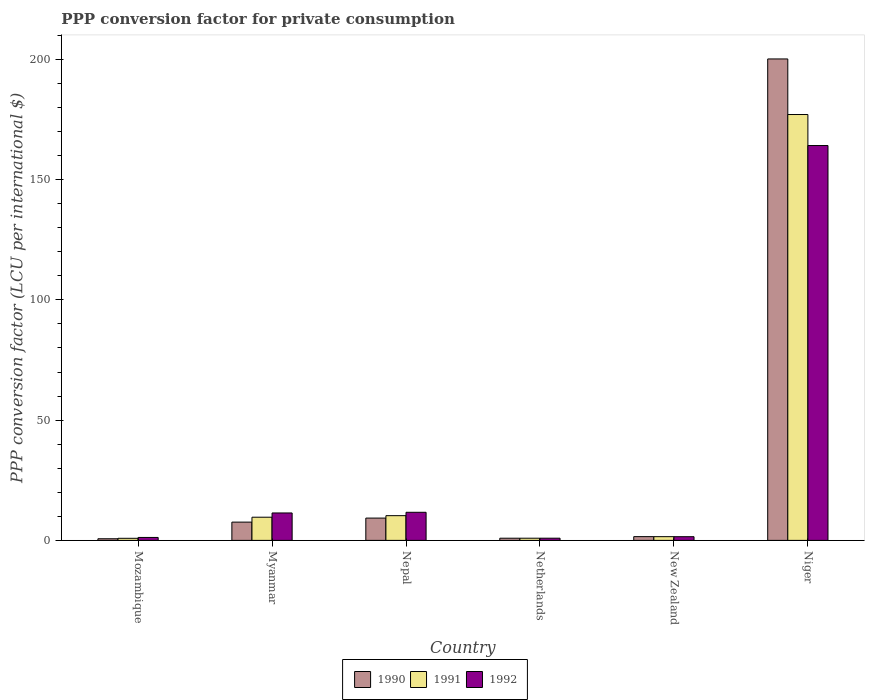Are the number of bars on each tick of the X-axis equal?
Ensure brevity in your answer.  Yes. What is the label of the 5th group of bars from the left?
Your answer should be compact. New Zealand. What is the PPP conversion factor for private consumption in 1991 in Myanmar?
Keep it short and to the point. 9.64. Across all countries, what is the maximum PPP conversion factor for private consumption in 1991?
Give a very brief answer. 177.06. Across all countries, what is the minimum PPP conversion factor for private consumption in 1991?
Provide a succinct answer. 0.87. In which country was the PPP conversion factor for private consumption in 1991 maximum?
Ensure brevity in your answer.  Niger. In which country was the PPP conversion factor for private consumption in 1990 minimum?
Ensure brevity in your answer.  Mozambique. What is the total PPP conversion factor for private consumption in 1990 in the graph?
Offer a very short reply. 220.18. What is the difference between the PPP conversion factor for private consumption in 1992 in Mozambique and that in Myanmar?
Give a very brief answer. -10.18. What is the difference between the PPP conversion factor for private consumption in 1991 in Myanmar and the PPP conversion factor for private consumption in 1990 in Mozambique?
Make the answer very short. 8.96. What is the average PPP conversion factor for private consumption in 1992 per country?
Keep it short and to the point. 31.82. What is the difference between the PPP conversion factor for private consumption of/in 1990 and PPP conversion factor for private consumption of/in 1991 in Niger?
Your answer should be compact. 23.1. In how many countries, is the PPP conversion factor for private consumption in 1992 greater than 80 LCU?
Provide a short and direct response. 1. What is the ratio of the PPP conversion factor for private consumption in 1992 in Myanmar to that in Netherlands?
Your answer should be compact. 12.49. Is the difference between the PPP conversion factor for private consumption in 1990 in Mozambique and Nepal greater than the difference between the PPP conversion factor for private consumption in 1991 in Mozambique and Nepal?
Give a very brief answer. Yes. What is the difference between the highest and the second highest PPP conversion factor for private consumption in 1990?
Ensure brevity in your answer.  190.89. What is the difference between the highest and the lowest PPP conversion factor for private consumption in 1992?
Your response must be concise. 163.25. In how many countries, is the PPP conversion factor for private consumption in 1992 greater than the average PPP conversion factor for private consumption in 1992 taken over all countries?
Your answer should be compact. 1. What does the 1st bar from the right in Myanmar represents?
Your answer should be very brief. 1992. Is it the case that in every country, the sum of the PPP conversion factor for private consumption in 1992 and PPP conversion factor for private consumption in 1990 is greater than the PPP conversion factor for private consumption in 1991?
Offer a terse response. Yes. How many bars are there?
Keep it short and to the point. 18. How many countries are there in the graph?
Your answer should be compact. 6. Are the values on the major ticks of Y-axis written in scientific E-notation?
Offer a terse response. No. Does the graph contain any zero values?
Provide a short and direct response. No. How many legend labels are there?
Keep it short and to the point. 3. How are the legend labels stacked?
Offer a terse response. Horizontal. What is the title of the graph?
Your answer should be compact. PPP conversion factor for private consumption. Does "1961" appear as one of the legend labels in the graph?
Provide a succinct answer. No. What is the label or title of the X-axis?
Ensure brevity in your answer.  Country. What is the label or title of the Y-axis?
Your response must be concise. PPP conversion factor (LCU per international $). What is the PPP conversion factor (LCU per international $) in 1990 in Mozambique?
Your response must be concise. 0.68. What is the PPP conversion factor (LCU per international $) in 1991 in Mozambique?
Give a very brief answer. 0.87. What is the PPP conversion factor (LCU per international $) in 1992 in Mozambique?
Offer a terse response. 1.22. What is the PPP conversion factor (LCU per international $) in 1990 in Myanmar?
Your answer should be very brief. 7.6. What is the PPP conversion factor (LCU per international $) in 1991 in Myanmar?
Provide a succinct answer. 9.64. What is the PPP conversion factor (LCU per international $) of 1992 in Myanmar?
Give a very brief answer. 11.41. What is the PPP conversion factor (LCU per international $) in 1990 in Nepal?
Ensure brevity in your answer.  9.27. What is the PPP conversion factor (LCU per international $) in 1991 in Nepal?
Provide a succinct answer. 10.28. What is the PPP conversion factor (LCU per international $) of 1992 in Nepal?
Ensure brevity in your answer.  11.69. What is the PPP conversion factor (LCU per international $) of 1990 in Netherlands?
Your answer should be compact. 0.91. What is the PPP conversion factor (LCU per international $) in 1991 in Netherlands?
Your answer should be very brief. 0.91. What is the PPP conversion factor (LCU per international $) in 1992 in Netherlands?
Offer a terse response. 0.91. What is the PPP conversion factor (LCU per international $) of 1990 in New Zealand?
Offer a very short reply. 1.56. What is the PPP conversion factor (LCU per international $) of 1991 in New Zealand?
Your response must be concise. 1.55. What is the PPP conversion factor (LCU per international $) of 1992 in New Zealand?
Keep it short and to the point. 1.53. What is the PPP conversion factor (LCU per international $) in 1990 in Niger?
Provide a succinct answer. 200.16. What is the PPP conversion factor (LCU per international $) in 1991 in Niger?
Provide a succinct answer. 177.06. What is the PPP conversion factor (LCU per international $) in 1992 in Niger?
Your response must be concise. 164.16. Across all countries, what is the maximum PPP conversion factor (LCU per international $) of 1990?
Your response must be concise. 200.16. Across all countries, what is the maximum PPP conversion factor (LCU per international $) of 1991?
Make the answer very short. 177.06. Across all countries, what is the maximum PPP conversion factor (LCU per international $) in 1992?
Make the answer very short. 164.16. Across all countries, what is the minimum PPP conversion factor (LCU per international $) in 1990?
Your response must be concise. 0.68. Across all countries, what is the minimum PPP conversion factor (LCU per international $) in 1991?
Provide a succinct answer. 0.87. Across all countries, what is the minimum PPP conversion factor (LCU per international $) of 1992?
Keep it short and to the point. 0.91. What is the total PPP conversion factor (LCU per international $) in 1990 in the graph?
Give a very brief answer. 220.18. What is the total PPP conversion factor (LCU per international $) of 1991 in the graph?
Your response must be concise. 200.3. What is the total PPP conversion factor (LCU per international $) in 1992 in the graph?
Keep it short and to the point. 190.92. What is the difference between the PPP conversion factor (LCU per international $) in 1990 in Mozambique and that in Myanmar?
Give a very brief answer. -6.92. What is the difference between the PPP conversion factor (LCU per international $) of 1991 in Mozambique and that in Myanmar?
Keep it short and to the point. -8.77. What is the difference between the PPP conversion factor (LCU per international $) of 1992 in Mozambique and that in Myanmar?
Provide a short and direct response. -10.18. What is the difference between the PPP conversion factor (LCU per international $) in 1990 in Mozambique and that in Nepal?
Provide a short and direct response. -8.59. What is the difference between the PPP conversion factor (LCU per international $) in 1991 in Mozambique and that in Nepal?
Make the answer very short. -9.41. What is the difference between the PPP conversion factor (LCU per international $) of 1992 in Mozambique and that in Nepal?
Ensure brevity in your answer.  -10.46. What is the difference between the PPP conversion factor (LCU per international $) in 1990 in Mozambique and that in Netherlands?
Offer a very short reply. -0.23. What is the difference between the PPP conversion factor (LCU per international $) in 1991 in Mozambique and that in Netherlands?
Ensure brevity in your answer.  -0.04. What is the difference between the PPP conversion factor (LCU per international $) in 1992 in Mozambique and that in Netherlands?
Make the answer very short. 0.31. What is the difference between the PPP conversion factor (LCU per international $) in 1990 in Mozambique and that in New Zealand?
Keep it short and to the point. -0.89. What is the difference between the PPP conversion factor (LCU per international $) in 1991 in Mozambique and that in New Zealand?
Ensure brevity in your answer.  -0.68. What is the difference between the PPP conversion factor (LCU per international $) of 1992 in Mozambique and that in New Zealand?
Ensure brevity in your answer.  -0.31. What is the difference between the PPP conversion factor (LCU per international $) of 1990 in Mozambique and that in Niger?
Make the answer very short. -199.48. What is the difference between the PPP conversion factor (LCU per international $) of 1991 in Mozambique and that in Niger?
Offer a terse response. -176.19. What is the difference between the PPP conversion factor (LCU per international $) in 1992 in Mozambique and that in Niger?
Your answer should be compact. -162.94. What is the difference between the PPP conversion factor (LCU per international $) in 1990 in Myanmar and that in Nepal?
Your answer should be compact. -1.67. What is the difference between the PPP conversion factor (LCU per international $) in 1991 in Myanmar and that in Nepal?
Provide a succinct answer. -0.64. What is the difference between the PPP conversion factor (LCU per international $) of 1992 in Myanmar and that in Nepal?
Give a very brief answer. -0.28. What is the difference between the PPP conversion factor (LCU per international $) of 1990 in Myanmar and that in Netherlands?
Your answer should be very brief. 6.69. What is the difference between the PPP conversion factor (LCU per international $) in 1991 in Myanmar and that in Netherlands?
Your answer should be very brief. 8.73. What is the difference between the PPP conversion factor (LCU per international $) in 1992 in Myanmar and that in Netherlands?
Offer a terse response. 10.49. What is the difference between the PPP conversion factor (LCU per international $) of 1990 in Myanmar and that in New Zealand?
Your answer should be very brief. 6.03. What is the difference between the PPP conversion factor (LCU per international $) of 1991 in Myanmar and that in New Zealand?
Make the answer very short. 8.09. What is the difference between the PPP conversion factor (LCU per international $) of 1992 in Myanmar and that in New Zealand?
Your response must be concise. 9.87. What is the difference between the PPP conversion factor (LCU per international $) in 1990 in Myanmar and that in Niger?
Provide a short and direct response. -192.57. What is the difference between the PPP conversion factor (LCU per international $) in 1991 in Myanmar and that in Niger?
Provide a succinct answer. -167.42. What is the difference between the PPP conversion factor (LCU per international $) of 1992 in Myanmar and that in Niger?
Ensure brevity in your answer.  -152.76. What is the difference between the PPP conversion factor (LCU per international $) of 1990 in Nepal and that in Netherlands?
Offer a very short reply. 8.36. What is the difference between the PPP conversion factor (LCU per international $) of 1991 in Nepal and that in Netherlands?
Your response must be concise. 9.37. What is the difference between the PPP conversion factor (LCU per international $) of 1992 in Nepal and that in Netherlands?
Give a very brief answer. 10.77. What is the difference between the PPP conversion factor (LCU per international $) in 1990 in Nepal and that in New Zealand?
Your response must be concise. 7.71. What is the difference between the PPP conversion factor (LCU per international $) in 1991 in Nepal and that in New Zealand?
Your response must be concise. 8.73. What is the difference between the PPP conversion factor (LCU per international $) of 1992 in Nepal and that in New Zealand?
Your answer should be compact. 10.15. What is the difference between the PPP conversion factor (LCU per international $) of 1990 in Nepal and that in Niger?
Keep it short and to the point. -190.89. What is the difference between the PPP conversion factor (LCU per international $) of 1991 in Nepal and that in Niger?
Offer a terse response. -166.78. What is the difference between the PPP conversion factor (LCU per international $) of 1992 in Nepal and that in Niger?
Your response must be concise. -152.47. What is the difference between the PPP conversion factor (LCU per international $) of 1990 in Netherlands and that in New Zealand?
Provide a short and direct response. -0.66. What is the difference between the PPP conversion factor (LCU per international $) of 1991 in Netherlands and that in New Zealand?
Provide a succinct answer. -0.64. What is the difference between the PPP conversion factor (LCU per international $) of 1992 in Netherlands and that in New Zealand?
Make the answer very short. -0.62. What is the difference between the PPP conversion factor (LCU per international $) of 1990 in Netherlands and that in Niger?
Your answer should be compact. -199.25. What is the difference between the PPP conversion factor (LCU per international $) in 1991 in Netherlands and that in Niger?
Keep it short and to the point. -176.15. What is the difference between the PPP conversion factor (LCU per international $) of 1992 in Netherlands and that in Niger?
Offer a terse response. -163.25. What is the difference between the PPP conversion factor (LCU per international $) of 1990 in New Zealand and that in Niger?
Make the answer very short. -198.6. What is the difference between the PPP conversion factor (LCU per international $) in 1991 in New Zealand and that in Niger?
Provide a succinct answer. -175.51. What is the difference between the PPP conversion factor (LCU per international $) in 1992 in New Zealand and that in Niger?
Your answer should be very brief. -162.63. What is the difference between the PPP conversion factor (LCU per international $) of 1990 in Mozambique and the PPP conversion factor (LCU per international $) of 1991 in Myanmar?
Provide a short and direct response. -8.96. What is the difference between the PPP conversion factor (LCU per international $) of 1990 in Mozambique and the PPP conversion factor (LCU per international $) of 1992 in Myanmar?
Offer a very short reply. -10.73. What is the difference between the PPP conversion factor (LCU per international $) in 1991 in Mozambique and the PPP conversion factor (LCU per international $) in 1992 in Myanmar?
Provide a short and direct response. -10.54. What is the difference between the PPP conversion factor (LCU per international $) in 1990 in Mozambique and the PPP conversion factor (LCU per international $) in 1991 in Nepal?
Ensure brevity in your answer.  -9.6. What is the difference between the PPP conversion factor (LCU per international $) of 1990 in Mozambique and the PPP conversion factor (LCU per international $) of 1992 in Nepal?
Your answer should be very brief. -11.01. What is the difference between the PPP conversion factor (LCU per international $) in 1991 in Mozambique and the PPP conversion factor (LCU per international $) in 1992 in Nepal?
Your answer should be very brief. -10.82. What is the difference between the PPP conversion factor (LCU per international $) of 1990 in Mozambique and the PPP conversion factor (LCU per international $) of 1991 in Netherlands?
Ensure brevity in your answer.  -0.23. What is the difference between the PPP conversion factor (LCU per international $) of 1990 in Mozambique and the PPP conversion factor (LCU per international $) of 1992 in Netherlands?
Make the answer very short. -0.23. What is the difference between the PPP conversion factor (LCU per international $) of 1991 in Mozambique and the PPP conversion factor (LCU per international $) of 1992 in Netherlands?
Provide a succinct answer. -0.05. What is the difference between the PPP conversion factor (LCU per international $) of 1990 in Mozambique and the PPP conversion factor (LCU per international $) of 1991 in New Zealand?
Provide a short and direct response. -0.87. What is the difference between the PPP conversion factor (LCU per international $) of 1990 in Mozambique and the PPP conversion factor (LCU per international $) of 1992 in New Zealand?
Offer a very short reply. -0.85. What is the difference between the PPP conversion factor (LCU per international $) in 1991 in Mozambique and the PPP conversion factor (LCU per international $) in 1992 in New Zealand?
Your answer should be compact. -0.67. What is the difference between the PPP conversion factor (LCU per international $) of 1990 in Mozambique and the PPP conversion factor (LCU per international $) of 1991 in Niger?
Your answer should be very brief. -176.38. What is the difference between the PPP conversion factor (LCU per international $) of 1990 in Mozambique and the PPP conversion factor (LCU per international $) of 1992 in Niger?
Make the answer very short. -163.48. What is the difference between the PPP conversion factor (LCU per international $) in 1991 in Mozambique and the PPP conversion factor (LCU per international $) in 1992 in Niger?
Your answer should be very brief. -163.29. What is the difference between the PPP conversion factor (LCU per international $) of 1990 in Myanmar and the PPP conversion factor (LCU per international $) of 1991 in Nepal?
Offer a very short reply. -2.68. What is the difference between the PPP conversion factor (LCU per international $) in 1990 in Myanmar and the PPP conversion factor (LCU per international $) in 1992 in Nepal?
Your response must be concise. -4.09. What is the difference between the PPP conversion factor (LCU per international $) of 1991 in Myanmar and the PPP conversion factor (LCU per international $) of 1992 in Nepal?
Provide a succinct answer. -2.05. What is the difference between the PPP conversion factor (LCU per international $) of 1990 in Myanmar and the PPP conversion factor (LCU per international $) of 1991 in Netherlands?
Your response must be concise. 6.69. What is the difference between the PPP conversion factor (LCU per international $) in 1990 in Myanmar and the PPP conversion factor (LCU per international $) in 1992 in Netherlands?
Give a very brief answer. 6.68. What is the difference between the PPP conversion factor (LCU per international $) of 1991 in Myanmar and the PPP conversion factor (LCU per international $) of 1992 in Netherlands?
Give a very brief answer. 8.73. What is the difference between the PPP conversion factor (LCU per international $) in 1990 in Myanmar and the PPP conversion factor (LCU per international $) in 1991 in New Zealand?
Your answer should be compact. 6.05. What is the difference between the PPP conversion factor (LCU per international $) of 1990 in Myanmar and the PPP conversion factor (LCU per international $) of 1992 in New Zealand?
Make the answer very short. 6.06. What is the difference between the PPP conversion factor (LCU per international $) of 1991 in Myanmar and the PPP conversion factor (LCU per international $) of 1992 in New Zealand?
Keep it short and to the point. 8.1. What is the difference between the PPP conversion factor (LCU per international $) of 1990 in Myanmar and the PPP conversion factor (LCU per international $) of 1991 in Niger?
Ensure brevity in your answer.  -169.46. What is the difference between the PPP conversion factor (LCU per international $) in 1990 in Myanmar and the PPP conversion factor (LCU per international $) in 1992 in Niger?
Offer a terse response. -156.56. What is the difference between the PPP conversion factor (LCU per international $) in 1991 in Myanmar and the PPP conversion factor (LCU per international $) in 1992 in Niger?
Keep it short and to the point. -154.52. What is the difference between the PPP conversion factor (LCU per international $) of 1990 in Nepal and the PPP conversion factor (LCU per international $) of 1991 in Netherlands?
Ensure brevity in your answer.  8.36. What is the difference between the PPP conversion factor (LCU per international $) in 1990 in Nepal and the PPP conversion factor (LCU per international $) in 1992 in Netherlands?
Your response must be concise. 8.36. What is the difference between the PPP conversion factor (LCU per international $) of 1991 in Nepal and the PPP conversion factor (LCU per international $) of 1992 in Netherlands?
Keep it short and to the point. 9.36. What is the difference between the PPP conversion factor (LCU per international $) of 1990 in Nepal and the PPP conversion factor (LCU per international $) of 1991 in New Zealand?
Give a very brief answer. 7.72. What is the difference between the PPP conversion factor (LCU per international $) in 1990 in Nepal and the PPP conversion factor (LCU per international $) in 1992 in New Zealand?
Make the answer very short. 7.74. What is the difference between the PPP conversion factor (LCU per international $) in 1991 in Nepal and the PPP conversion factor (LCU per international $) in 1992 in New Zealand?
Your answer should be very brief. 8.74. What is the difference between the PPP conversion factor (LCU per international $) of 1990 in Nepal and the PPP conversion factor (LCU per international $) of 1991 in Niger?
Provide a short and direct response. -167.79. What is the difference between the PPP conversion factor (LCU per international $) in 1990 in Nepal and the PPP conversion factor (LCU per international $) in 1992 in Niger?
Ensure brevity in your answer.  -154.89. What is the difference between the PPP conversion factor (LCU per international $) of 1991 in Nepal and the PPP conversion factor (LCU per international $) of 1992 in Niger?
Offer a terse response. -153.88. What is the difference between the PPP conversion factor (LCU per international $) in 1990 in Netherlands and the PPP conversion factor (LCU per international $) in 1991 in New Zealand?
Offer a terse response. -0.64. What is the difference between the PPP conversion factor (LCU per international $) of 1990 in Netherlands and the PPP conversion factor (LCU per international $) of 1992 in New Zealand?
Your answer should be compact. -0.63. What is the difference between the PPP conversion factor (LCU per international $) of 1991 in Netherlands and the PPP conversion factor (LCU per international $) of 1992 in New Zealand?
Your answer should be compact. -0.62. What is the difference between the PPP conversion factor (LCU per international $) in 1990 in Netherlands and the PPP conversion factor (LCU per international $) in 1991 in Niger?
Make the answer very short. -176.15. What is the difference between the PPP conversion factor (LCU per international $) of 1990 in Netherlands and the PPP conversion factor (LCU per international $) of 1992 in Niger?
Your response must be concise. -163.25. What is the difference between the PPP conversion factor (LCU per international $) in 1991 in Netherlands and the PPP conversion factor (LCU per international $) in 1992 in Niger?
Your answer should be very brief. -163.25. What is the difference between the PPP conversion factor (LCU per international $) of 1990 in New Zealand and the PPP conversion factor (LCU per international $) of 1991 in Niger?
Keep it short and to the point. -175.49. What is the difference between the PPP conversion factor (LCU per international $) in 1990 in New Zealand and the PPP conversion factor (LCU per international $) in 1992 in Niger?
Keep it short and to the point. -162.6. What is the difference between the PPP conversion factor (LCU per international $) in 1991 in New Zealand and the PPP conversion factor (LCU per international $) in 1992 in Niger?
Provide a succinct answer. -162.61. What is the average PPP conversion factor (LCU per international $) of 1990 per country?
Give a very brief answer. 36.7. What is the average PPP conversion factor (LCU per international $) of 1991 per country?
Provide a short and direct response. 33.38. What is the average PPP conversion factor (LCU per international $) of 1992 per country?
Provide a short and direct response. 31.82. What is the difference between the PPP conversion factor (LCU per international $) in 1990 and PPP conversion factor (LCU per international $) in 1991 in Mozambique?
Keep it short and to the point. -0.19. What is the difference between the PPP conversion factor (LCU per international $) of 1990 and PPP conversion factor (LCU per international $) of 1992 in Mozambique?
Your answer should be compact. -0.54. What is the difference between the PPP conversion factor (LCU per international $) in 1991 and PPP conversion factor (LCU per international $) in 1992 in Mozambique?
Your answer should be very brief. -0.36. What is the difference between the PPP conversion factor (LCU per international $) in 1990 and PPP conversion factor (LCU per international $) in 1991 in Myanmar?
Your answer should be compact. -2.04. What is the difference between the PPP conversion factor (LCU per international $) in 1990 and PPP conversion factor (LCU per international $) in 1992 in Myanmar?
Give a very brief answer. -3.81. What is the difference between the PPP conversion factor (LCU per international $) of 1991 and PPP conversion factor (LCU per international $) of 1992 in Myanmar?
Offer a terse response. -1.77. What is the difference between the PPP conversion factor (LCU per international $) of 1990 and PPP conversion factor (LCU per international $) of 1991 in Nepal?
Make the answer very short. -1.01. What is the difference between the PPP conversion factor (LCU per international $) of 1990 and PPP conversion factor (LCU per international $) of 1992 in Nepal?
Keep it short and to the point. -2.42. What is the difference between the PPP conversion factor (LCU per international $) in 1991 and PPP conversion factor (LCU per international $) in 1992 in Nepal?
Give a very brief answer. -1.41. What is the difference between the PPP conversion factor (LCU per international $) of 1990 and PPP conversion factor (LCU per international $) of 1991 in Netherlands?
Provide a short and direct response. -0. What is the difference between the PPP conversion factor (LCU per international $) of 1990 and PPP conversion factor (LCU per international $) of 1992 in Netherlands?
Keep it short and to the point. -0.01. What is the difference between the PPP conversion factor (LCU per international $) of 1991 and PPP conversion factor (LCU per international $) of 1992 in Netherlands?
Provide a short and direct response. -0. What is the difference between the PPP conversion factor (LCU per international $) in 1990 and PPP conversion factor (LCU per international $) in 1991 in New Zealand?
Offer a very short reply. 0.01. What is the difference between the PPP conversion factor (LCU per international $) of 1990 and PPP conversion factor (LCU per international $) of 1992 in New Zealand?
Offer a very short reply. 0.03. What is the difference between the PPP conversion factor (LCU per international $) in 1991 and PPP conversion factor (LCU per international $) in 1992 in New Zealand?
Provide a succinct answer. 0.02. What is the difference between the PPP conversion factor (LCU per international $) of 1990 and PPP conversion factor (LCU per international $) of 1991 in Niger?
Give a very brief answer. 23.1. What is the difference between the PPP conversion factor (LCU per international $) in 1990 and PPP conversion factor (LCU per international $) in 1992 in Niger?
Offer a terse response. 36. What is the difference between the PPP conversion factor (LCU per international $) in 1991 and PPP conversion factor (LCU per international $) in 1992 in Niger?
Provide a short and direct response. 12.9. What is the ratio of the PPP conversion factor (LCU per international $) in 1990 in Mozambique to that in Myanmar?
Your response must be concise. 0.09. What is the ratio of the PPP conversion factor (LCU per international $) of 1991 in Mozambique to that in Myanmar?
Offer a very short reply. 0.09. What is the ratio of the PPP conversion factor (LCU per international $) in 1992 in Mozambique to that in Myanmar?
Give a very brief answer. 0.11. What is the ratio of the PPP conversion factor (LCU per international $) in 1990 in Mozambique to that in Nepal?
Provide a succinct answer. 0.07. What is the ratio of the PPP conversion factor (LCU per international $) of 1991 in Mozambique to that in Nepal?
Provide a short and direct response. 0.08. What is the ratio of the PPP conversion factor (LCU per international $) in 1992 in Mozambique to that in Nepal?
Offer a very short reply. 0.1. What is the ratio of the PPP conversion factor (LCU per international $) in 1990 in Mozambique to that in Netherlands?
Provide a succinct answer. 0.75. What is the ratio of the PPP conversion factor (LCU per international $) of 1991 in Mozambique to that in Netherlands?
Give a very brief answer. 0.95. What is the ratio of the PPP conversion factor (LCU per international $) of 1992 in Mozambique to that in Netherlands?
Give a very brief answer. 1.34. What is the ratio of the PPP conversion factor (LCU per international $) in 1990 in Mozambique to that in New Zealand?
Provide a short and direct response. 0.43. What is the ratio of the PPP conversion factor (LCU per international $) in 1991 in Mozambique to that in New Zealand?
Your answer should be very brief. 0.56. What is the ratio of the PPP conversion factor (LCU per international $) in 1992 in Mozambique to that in New Zealand?
Ensure brevity in your answer.  0.8. What is the ratio of the PPP conversion factor (LCU per international $) of 1990 in Mozambique to that in Niger?
Provide a short and direct response. 0. What is the ratio of the PPP conversion factor (LCU per international $) in 1991 in Mozambique to that in Niger?
Keep it short and to the point. 0. What is the ratio of the PPP conversion factor (LCU per international $) in 1992 in Mozambique to that in Niger?
Offer a terse response. 0.01. What is the ratio of the PPP conversion factor (LCU per international $) in 1990 in Myanmar to that in Nepal?
Your answer should be very brief. 0.82. What is the ratio of the PPP conversion factor (LCU per international $) in 1991 in Myanmar to that in Nepal?
Keep it short and to the point. 0.94. What is the ratio of the PPP conversion factor (LCU per international $) in 1992 in Myanmar to that in Nepal?
Ensure brevity in your answer.  0.98. What is the ratio of the PPP conversion factor (LCU per international $) in 1990 in Myanmar to that in Netherlands?
Ensure brevity in your answer.  8.38. What is the ratio of the PPP conversion factor (LCU per international $) in 1991 in Myanmar to that in Netherlands?
Offer a very short reply. 10.6. What is the ratio of the PPP conversion factor (LCU per international $) in 1992 in Myanmar to that in Netherlands?
Provide a succinct answer. 12.49. What is the ratio of the PPP conversion factor (LCU per international $) of 1990 in Myanmar to that in New Zealand?
Keep it short and to the point. 4.85. What is the ratio of the PPP conversion factor (LCU per international $) in 1991 in Myanmar to that in New Zealand?
Make the answer very short. 6.22. What is the ratio of the PPP conversion factor (LCU per international $) of 1992 in Myanmar to that in New Zealand?
Provide a succinct answer. 7.44. What is the ratio of the PPP conversion factor (LCU per international $) of 1990 in Myanmar to that in Niger?
Make the answer very short. 0.04. What is the ratio of the PPP conversion factor (LCU per international $) in 1991 in Myanmar to that in Niger?
Make the answer very short. 0.05. What is the ratio of the PPP conversion factor (LCU per international $) of 1992 in Myanmar to that in Niger?
Your answer should be compact. 0.07. What is the ratio of the PPP conversion factor (LCU per international $) in 1990 in Nepal to that in Netherlands?
Keep it short and to the point. 10.23. What is the ratio of the PPP conversion factor (LCU per international $) in 1991 in Nepal to that in Netherlands?
Offer a very short reply. 11.31. What is the ratio of the PPP conversion factor (LCU per international $) in 1992 in Nepal to that in Netherlands?
Provide a succinct answer. 12.8. What is the ratio of the PPP conversion factor (LCU per international $) of 1990 in Nepal to that in New Zealand?
Give a very brief answer. 5.92. What is the ratio of the PPP conversion factor (LCU per international $) in 1991 in Nepal to that in New Zealand?
Offer a terse response. 6.63. What is the ratio of the PPP conversion factor (LCU per international $) in 1992 in Nepal to that in New Zealand?
Ensure brevity in your answer.  7.62. What is the ratio of the PPP conversion factor (LCU per international $) in 1990 in Nepal to that in Niger?
Keep it short and to the point. 0.05. What is the ratio of the PPP conversion factor (LCU per international $) of 1991 in Nepal to that in Niger?
Your answer should be very brief. 0.06. What is the ratio of the PPP conversion factor (LCU per international $) of 1992 in Nepal to that in Niger?
Keep it short and to the point. 0.07. What is the ratio of the PPP conversion factor (LCU per international $) of 1990 in Netherlands to that in New Zealand?
Offer a terse response. 0.58. What is the ratio of the PPP conversion factor (LCU per international $) in 1991 in Netherlands to that in New Zealand?
Your answer should be compact. 0.59. What is the ratio of the PPP conversion factor (LCU per international $) in 1992 in Netherlands to that in New Zealand?
Your response must be concise. 0.6. What is the ratio of the PPP conversion factor (LCU per international $) of 1990 in Netherlands to that in Niger?
Your answer should be compact. 0. What is the ratio of the PPP conversion factor (LCU per international $) in 1991 in Netherlands to that in Niger?
Your answer should be compact. 0.01. What is the ratio of the PPP conversion factor (LCU per international $) of 1992 in Netherlands to that in Niger?
Provide a succinct answer. 0.01. What is the ratio of the PPP conversion factor (LCU per international $) in 1990 in New Zealand to that in Niger?
Your answer should be compact. 0.01. What is the ratio of the PPP conversion factor (LCU per international $) in 1991 in New Zealand to that in Niger?
Give a very brief answer. 0.01. What is the ratio of the PPP conversion factor (LCU per international $) of 1992 in New Zealand to that in Niger?
Offer a very short reply. 0.01. What is the difference between the highest and the second highest PPP conversion factor (LCU per international $) of 1990?
Provide a succinct answer. 190.89. What is the difference between the highest and the second highest PPP conversion factor (LCU per international $) in 1991?
Give a very brief answer. 166.78. What is the difference between the highest and the second highest PPP conversion factor (LCU per international $) of 1992?
Offer a terse response. 152.47. What is the difference between the highest and the lowest PPP conversion factor (LCU per international $) of 1990?
Keep it short and to the point. 199.48. What is the difference between the highest and the lowest PPP conversion factor (LCU per international $) in 1991?
Ensure brevity in your answer.  176.19. What is the difference between the highest and the lowest PPP conversion factor (LCU per international $) of 1992?
Keep it short and to the point. 163.25. 